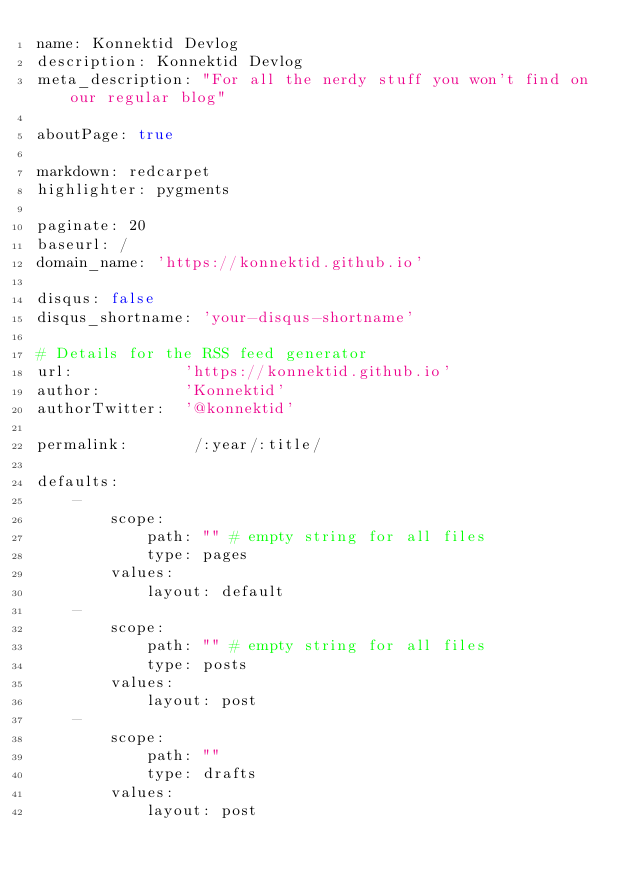<code> <loc_0><loc_0><loc_500><loc_500><_YAML_>name: Konnektid Devlog
description: Konnektid Devlog
meta_description: "For all the nerdy stuff you won't find on our regular blog"

aboutPage: true

markdown: redcarpet
highlighter: pygments

paginate: 20
baseurl: /
domain_name: 'https://konnektid.github.io'

disqus: false
disqus_shortname: 'your-disqus-shortname'

# Details for the RSS feed generator
url:            'https://konnektid.github.io'
author:         'Konnektid'
authorTwitter:  '@konnektid'

permalink:       /:year/:title/

defaults:
    -
        scope:
            path: "" # empty string for all files
            type: pages
        values:
            layout: default
    -
        scope:
            path: "" # empty string for all files
            type: posts
        values:
            layout: post
    -
        scope:
            path: ""
            type: drafts
        values:
            layout: post
</code> 